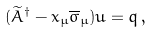<formula> <loc_0><loc_0><loc_500><loc_500>( \widetilde { A } ^ { \dagger } - x _ { \mu } \overline { \sigma } _ { \mu } ) u = q \, ,</formula> 